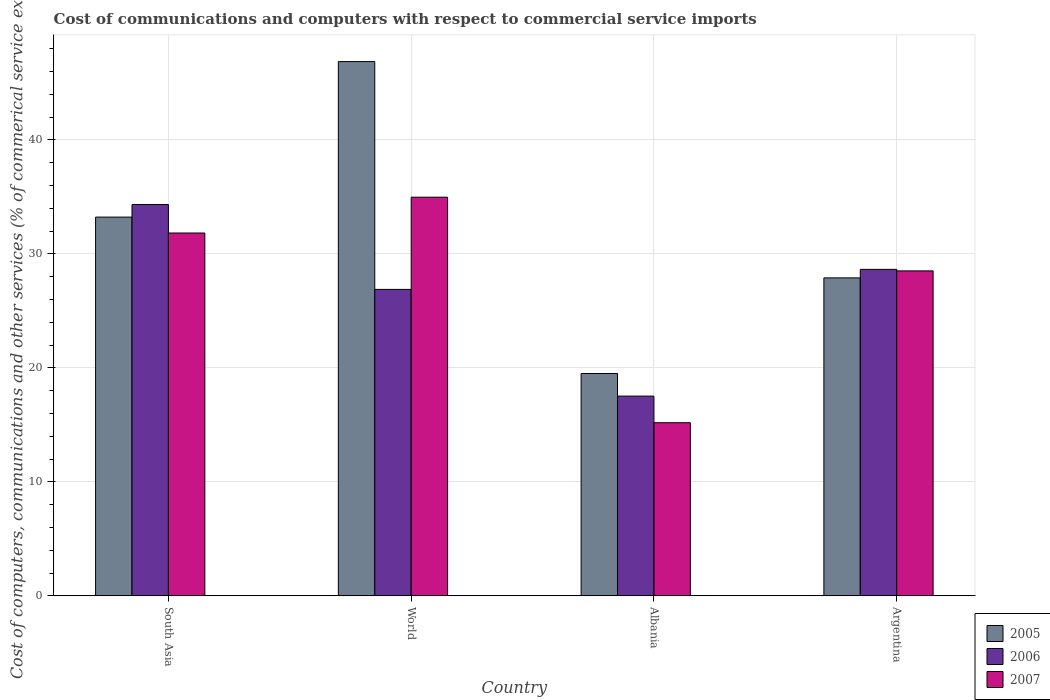How many different coloured bars are there?
Your answer should be very brief. 3. How many groups of bars are there?
Give a very brief answer. 4. How many bars are there on the 4th tick from the left?
Your response must be concise. 3. What is the label of the 1st group of bars from the left?
Provide a succinct answer. South Asia. In how many cases, is the number of bars for a given country not equal to the number of legend labels?
Give a very brief answer. 0. What is the cost of communications and computers in 2005 in Argentina?
Make the answer very short. 27.89. Across all countries, what is the maximum cost of communications and computers in 2007?
Ensure brevity in your answer.  34.97. Across all countries, what is the minimum cost of communications and computers in 2007?
Provide a short and direct response. 15.19. In which country was the cost of communications and computers in 2005 minimum?
Keep it short and to the point. Albania. What is the total cost of communications and computers in 2007 in the graph?
Your answer should be compact. 110.49. What is the difference between the cost of communications and computers in 2007 in Argentina and that in World?
Offer a very short reply. -6.46. What is the difference between the cost of communications and computers in 2007 in World and the cost of communications and computers in 2005 in Argentina?
Your answer should be compact. 7.08. What is the average cost of communications and computers in 2006 per country?
Your answer should be very brief. 26.84. What is the difference between the cost of communications and computers of/in 2005 and cost of communications and computers of/in 2007 in Argentina?
Make the answer very short. -0.61. What is the ratio of the cost of communications and computers in 2006 in Albania to that in World?
Give a very brief answer. 0.65. Is the cost of communications and computers in 2005 in South Asia less than that in World?
Provide a short and direct response. Yes. What is the difference between the highest and the second highest cost of communications and computers in 2007?
Offer a very short reply. 6.46. What is the difference between the highest and the lowest cost of communications and computers in 2005?
Offer a very short reply. 27.36. Is the sum of the cost of communications and computers in 2005 in Albania and South Asia greater than the maximum cost of communications and computers in 2007 across all countries?
Ensure brevity in your answer.  Yes. What does the 1st bar from the left in Albania represents?
Make the answer very short. 2005. What does the 3rd bar from the right in South Asia represents?
Your response must be concise. 2005. How many bars are there?
Keep it short and to the point. 12. Are all the bars in the graph horizontal?
Your answer should be compact. No. Are the values on the major ticks of Y-axis written in scientific E-notation?
Offer a terse response. No. Does the graph contain any zero values?
Provide a short and direct response. No. Where does the legend appear in the graph?
Keep it short and to the point. Bottom right. How many legend labels are there?
Provide a short and direct response. 3. How are the legend labels stacked?
Offer a very short reply. Vertical. What is the title of the graph?
Your response must be concise. Cost of communications and computers with respect to commercial service imports. Does "2013" appear as one of the legend labels in the graph?
Keep it short and to the point. No. What is the label or title of the Y-axis?
Your answer should be compact. Cost of computers, communications and other services (% of commerical service exports). What is the Cost of computers, communications and other services (% of commerical service exports) in 2005 in South Asia?
Make the answer very short. 33.22. What is the Cost of computers, communications and other services (% of commerical service exports) of 2006 in South Asia?
Offer a terse response. 34.33. What is the Cost of computers, communications and other services (% of commerical service exports) of 2007 in South Asia?
Offer a terse response. 31.83. What is the Cost of computers, communications and other services (% of commerical service exports) of 2005 in World?
Your answer should be compact. 46.86. What is the Cost of computers, communications and other services (% of commerical service exports) in 2006 in World?
Your response must be concise. 26.88. What is the Cost of computers, communications and other services (% of commerical service exports) of 2007 in World?
Keep it short and to the point. 34.97. What is the Cost of computers, communications and other services (% of commerical service exports) in 2005 in Albania?
Give a very brief answer. 19.5. What is the Cost of computers, communications and other services (% of commerical service exports) of 2006 in Albania?
Your answer should be very brief. 17.52. What is the Cost of computers, communications and other services (% of commerical service exports) of 2007 in Albania?
Ensure brevity in your answer.  15.19. What is the Cost of computers, communications and other services (% of commerical service exports) in 2005 in Argentina?
Your answer should be compact. 27.89. What is the Cost of computers, communications and other services (% of commerical service exports) in 2006 in Argentina?
Offer a terse response. 28.64. What is the Cost of computers, communications and other services (% of commerical service exports) of 2007 in Argentina?
Give a very brief answer. 28.5. Across all countries, what is the maximum Cost of computers, communications and other services (% of commerical service exports) in 2005?
Give a very brief answer. 46.86. Across all countries, what is the maximum Cost of computers, communications and other services (% of commerical service exports) of 2006?
Make the answer very short. 34.33. Across all countries, what is the maximum Cost of computers, communications and other services (% of commerical service exports) in 2007?
Give a very brief answer. 34.97. Across all countries, what is the minimum Cost of computers, communications and other services (% of commerical service exports) of 2005?
Your answer should be compact. 19.5. Across all countries, what is the minimum Cost of computers, communications and other services (% of commerical service exports) of 2006?
Provide a succinct answer. 17.52. Across all countries, what is the minimum Cost of computers, communications and other services (% of commerical service exports) in 2007?
Provide a short and direct response. 15.19. What is the total Cost of computers, communications and other services (% of commerical service exports) in 2005 in the graph?
Offer a terse response. 127.48. What is the total Cost of computers, communications and other services (% of commerical service exports) in 2006 in the graph?
Offer a terse response. 107.36. What is the total Cost of computers, communications and other services (% of commerical service exports) in 2007 in the graph?
Make the answer very short. 110.49. What is the difference between the Cost of computers, communications and other services (% of commerical service exports) of 2005 in South Asia and that in World?
Offer a terse response. -13.64. What is the difference between the Cost of computers, communications and other services (% of commerical service exports) of 2006 in South Asia and that in World?
Provide a succinct answer. 7.45. What is the difference between the Cost of computers, communications and other services (% of commerical service exports) of 2007 in South Asia and that in World?
Make the answer very short. -3.14. What is the difference between the Cost of computers, communications and other services (% of commerical service exports) in 2005 in South Asia and that in Albania?
Provide a short and direct response. 13.72. What is the difference between the Cost of computers, communications and other services (% of commerical service exports) in 2006 in South Asia and that in Albania?
Ensure brevity in your answer.  16.81. What is the difference between the Cost of computers, communications and other services (% of commerical service exports) of 2007 in South Asia and that in Albania?
Offer a very short reply. 16.64. What is the difference between the Cost of computers, communications and other services (% of commerical service exports) in 2005 in South Asia and that in Argentina?
Provide a succinct answer. 5.33. What is the difference between the Cost of computers, communications and other services (% of commerical service exports) of 2006 in South Asia and that in Argentina?
Ensure brevity in your answer.  5.69. What is the difference between the Cost of computers, communications and other services (% of commerical service exports) in 2007 in South Asia and that in Argentina?
Provide a short and direct response. 3.32. What is the difference between the Cost of computers, communications and other services (% of commerical service exports) of 2005 in World and that in Albania?
Keep it short and to the point. 27.36. What is the difference between the Cost of computers, communications and other services (% of commerical service exports) in 2006 in World and that in Albania?
Offer a very short reply. 9.36. What is the difference between the Cost of computers, communications and other services (% of commerical service exports) of 2007 in World and that in Albania?
Your response must be concise. 19.78. What is the difference between the Cost of computers, communications and other services (% of commerical service exports) of 2005 in World and that in Argentina?
Offer a very short reply. 18.97. What is the difference between the Cost of computers, communications and other services (% of commerical service exports) of 2006 in World and that in Argentina?
Your response must be concise. -1.76. What is the difference between the Cost of computers, communications and other services (% of commerical service exports) of 2007 in World and that in Argentina?
Offer a terse response. 6.46. What is the difference between the Cost of computers, communications and other services (% of commerical service exports) in 2005 in Albania and that in Argentina?
Your answer should be very brief. -8.39. What is the difference between the Cost of computers, communications and other services (% of commerical service exports) of 2006 in Albania and that in Argentina?
Ensure brevity in your answer.  -11.12. What is the difference between the Cost of computers, communications and other services (% of commerical service exports) of 2007 in Albania and that in Argentina?
Make the answer very short. -13.32. What is the difference between the Cost of computers, communications and other services (% of commerical service exports) of 2005 in South Asia and the Cost of computers, communications and other services (% of commerical service exports) of 2006 in World?
Keep it short and to the point. 6.34. What is the difference between the Cost of computers, communications and other services (% of commerical service exports) of 2005 in South Asia and the Cost of computers, communications and other services (% of commerical service exports) of 2007 in World?
Ensure brevity in your answer.  -1.75. What is the difference between the Cost of computers, communications and other services (% of commerical service exports) of 2006 in South Asia and the Cost of computers, communications and other services (% of commerical service exports) of 2007 in World?
Provide a succinct answer. -0.64. What is the difference between the Cost of computers, communications and other services (% of commerical service exports) of 2005 in South Asia and the Cost of computers, communications and other services (% of commerical service exports) of 2006 in Albania?
Offer a terse response. 15.7. What is the difference between the Cost of computers, communications and other services (% of commerical service exports) of 2005 in South Asia and the Cost of computers, communications and other services (% of commerical service exports) of 2007 in Albania?
Provide a succinct answer. 18.03. What is the difference between the Cost of computers, communications and other services (% of commerical service exports) in 2006 in South Asia and the Cost of computers, communications and other services (% of commerical service exports) in 2007 in Albania?
Provide a short and direct response. 19.14. What is the difference between the Cost of computers, communications and other services (% of commerical service exports) in 2005 in South Asia and the Cost of computers, communications and other services (% of commerical service exports) in 2006 in Argentina?
Your answer should be compact. 4.58. What is the difference between the Cost of computers, communications and other services (% of commerical service exports) of 2005 in South Asia and the Cost of computers, communications and other services (% of commerical service exports) of 2007 in Argentina?
Provide a succinct answer. 4.72. What is the difference between the Cost of computers, communications and other services (% of commerical service exports) of 2006 in South Asia and the Cost of computers, communications and other services (% of commerical service exports) of 2007 in Argentina?
Provide a short and direct response. 5.82. What is the difference between the Cost of computers, communications and other services (% of commerical service exports) of 2005 in World and the Cost of computers, communications and other services (% of commerical service exports) of 2006 in Albania?
Make the answer very short. 29.34. What is the difference between the Cost of computers, communications and other services (% of commerical service exports) of 2005 in World and the Cost of computers, communications and other services (% of commerical service exports) of 2007 in Albania?
Keep it short and to the point. 31.68. What is the difference between the Cost of computers, communications and other services (% of commerical service exports) in 2006 in World and the Cost of computers, communications and other services (% of commerical service exports) in 2007 in Albania?
Offer a terse response. 11.69. What is the difference between the Cost of computers, communications and other services (% of commerical service exports) of 2005 in World and the Cost of computers, communications and other services (% of commerical service exports) of 2006 in Argentina?
Ensure brevity in your answer.  18.23. What is the difference between the Cost of computers, communications and other services (% of commerical service exports) in 2005 in World and the Cost of computers, communications and other services (% of commerical service exports) in 2007 in Argentina?
Provide a short and direct response. 18.36. What is the difference between the Cost of computers, communications and other services (% of commerical service exports) of 2006 in World and the Cost of computers, communications and other services (% of commerical service exports) of 2007 in Argentina?
Ensure brevity in your answer.  -1.62. What is the difference between the Cost of computers, communications and other services (% of commerical service exports) in 2005 in Albania and the Cost of computers, communications and other services (% of commerical service exports) in 2006 in Argentina?
Provide a short and direct response. -9.13. What is the difference between the Cost of computers, communications and other services (% of commerical service exports) of 2005 in Albania and the Cost of computers, communications and other services (% of commerical service exports) of 2007 in Argentina?
Give a very brief answer. -9. What is the difference between the Cost of computers, communications and other services (% of commerical service exports) of 2006 in Albania and the Cost of computers, communications and other services (% of commerical service exports) of 2007 in Argentina?
Make the answer very short. -10.98. What is the average Cost of computers, communications and other services (% of commerical service exports) in 2005 per country?
Ensure brevity in your answer.  31.87. What is the average Cost of computers, communications and other services (% of commerical service exports) of 2006 per country?
Your answer should be compact. 26.84. What is the average Cost of computers, communications and other services (% of commerical service exports) of 2007 per country?
Your answer should be compact. 27.62. What is the difference between the Cost of computers, communications and other services (% of commerical service exports) of 2005 and Cost of computers, communications and other services (% of commerical service exports) of 2006 in South Asia?
Your response must be concise. -1.1. What is the difference between the Cost of computers, communications and other services (% of commerical service exports) of 2005 and Cost of computers, communications and other services (% of commerical service exports) of 2007 in South Asia?
Your answer should be compact. 1.39. What is the difference between the Cost of computers, communications and other services (% of commerical service exports) in 2006 and Cost of computers, communications and other services (% of commerical service exports) in 2007 in South Asia?
Your answer should be very brief. 2.5. What is the difference between the Cost of computers, communications and other services (% of commerical service exports) in 2005 and Cost of computers, communications and other services (% of commerical service exports) in 2006 in World?
Provide a short and direct response. 19.98. What is the difference between the Cost of computers, communications and other services (% of commerical service exports) in 2005 and Cost of computers, communications and other services (% of commerical service exports) in 2007 in World?
Your answer should be compact. 11.89. What is the difference between the Cost of computers, communications and other services (% of commerical service exports) of 2006 and Cost of computers, communications and other services (% of commerical service exports) of 2007 in World?
Provide a short and direct response. -8.09. What is the difference between the Cost of computers, communications and other services (% of commerical service exports) of 2005 and Cost of computers, communications and other services (% of commerical service exports) of 2006 in Albania?
Offer a very short reply. 1.98. What is the difference between the Cost of computers, communications and other services (% of commerical service exports) in 2005 and Cost of computers, communications and other services (% of commerical service exports) in 2007 in Albania?
Provide a succinct answer. 4.32. What is the difference between the Cost of computers, communications and other services (% of commerical service exports) of 2006 and Cost of computers, communications and other services (% of commerical service exports) of 2007 in Albania?
Your response must be concise. 2.33. What is the difference between the Cost of computers, communications and other services (% of commerical service exports) of 2005 and Cost of computers, communications and other services (% of commerical service exports) of 2006 in Argentina?
Your answer should be compact. -0.75. What is the difference between the Cost of computers, communications and other services (% of commerical service exports) of 2005 and Cost of computers, communications and other services (% of commerical service exports) of 2007 in Argentina?
Your answer should be compact. -0.61. What is the difference between the Cost of computers, communications and other services (% of commerical service exports) in 2006 and Cost of computers, communications and other services (% of commerical service exports) in 2007 in Argentina?
Provide a succinct answer. 0.13. What is the ratio of the Cost of computers, communications and other services (% of commerical service exports) in 2005 in South Asia to that in World?
Provide a short and direct response. 0.71. What is the ratio of the Cost of computers, communications and other services (% of commerical service exports) in 2006 in South Asia to that in World?
Provide a succinct answer. 1.28. What is the ratio of the Cost of computers, communications and other services (% of commerical service exports) of 2007 in South Asia to that in World?
Your answer should be very brief. 0.91. What is the ratio of the Cost of computers, communications and other services (% of commerical service exports) in 2005 in South Asia to that in Albania?
Offer a terse response. 1.7. What is the ratio of the Cost of computers, communications and other services (% of commerical service exports) of 2006 in South Asia to that in Albania?
Your answer should be compact. 1.96. What is the ratio of the Cost of computers, communications and other services (% of commerical service exports) of 2007 in South Asia to that in Albania?
Your response must be concise. 2.1. What is the ratio of the Cost of computers, communications and other services (% of commerical service exports) of 2005 in South Asia to that in Argentina?
Your response must be concise. 1.19. What is the ratio of the Cost of computers, communications and other services (% of commerical service exports) in 2006 in South Asia to that in Argentina?
Provide a short and direct response. 1.2. What is the ratio of the Cost of computers, communications and other services (% of commerical service exports) in 2007 in South Asia to that in Argentina?
Make the answer very short. 1.12. What is the ratio of the Cost of computers, communications and other services (% of commerical service exports) of 2005 in World to that in Albania?
Keep it short and to the point. 2.4. What is the ratio of the Cost of computers, communications and other services (% of commerical service exports) in 2006 in World to that in Albania?
Your response must be concise. 1.53. What is the ratio of the Cost of computers, communications and other services (% of commerical service exports) in 2007 in World to that in Albania?
Offer a very short reply. 2.3. What is the ratio of the Cost of computers, communications and other services (% of commerical service exports) in 2005 in World to that in Argentina?
Keep it short and to the point. 1.68. What is the ratio of the Cost of computers, communications and other services (% of commerical service exports) in 2006 in World to that in Argentina?
Your response must be concise. 0.94. What is the ratio of the Cost of computers, communications and other services (% of commerical service exports) of 2007 in World to that in Argentina?
Offer a terse response. 1.23. What is the ratio of the Cost of computers, communications and other services (% of commerical service exports) in 2005 in Albania to that in Argentina?
Your response must be concise. 0.7. What is the ratio of the Cost of computers, communications and other services (% of commerical service exports) in 2006 in Albania to that in Argentina?
Your response must be concise. 0.61. What is the ratio of the Cost of computers, communications and other services (% of commerical service exports) of 2007 in Albania to that in Argentina?
Your answer should be very brief. 0.53. What is the difference between the highest and the second highest Cost of computers, communications and other services (% of commerical service exports) in 2005?
Offer a very short reply. 13.64. What is the difference between the highest and the second highest Cost of computers, communications and other services (% of commerical service exports) of 2006?
Make the answer very short. 5.69. What is the difference between the highest and the second highest Cost of computers, communications and other services (% of commerical service exports) of 2007?
Provide a succinct answer. 3.14. What is the difference between the highest and the lowest Cost of computers, communications and other services (% of commerical service exports) of 2005?
Make the answer very short. 27.36. What is the difference between the highest and the lowest Cost of computers, communications and other services (% of commerical service exports) of 2006?
Keep it short and to the point. 16.81. What is the difference between the highest and the lowest Cost of computers, communications and other services (% of commerical service exports) of 2007?
Your answer should be very brief. 19.78. 